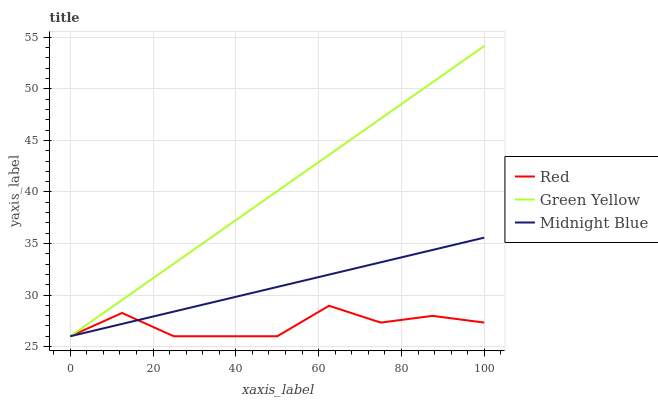Does Red have the minimum area under the curve?
Answer yes or no. Yes. Does Green Yellow have the maximum area under the curve?
Answer yes or no. Yes. Does Midnight Blue have the minimum area under the curve?
Answer yes or no. No. Does Midnight Blue have the maximum area under the curve?
Answer yes or no. No. Is Green Yellow the smoothest?
Answer yes or no. Yes. Is Red the roughest?
Answer yes or no. Yes. Is Midnight Blue the smoothest?
Answer yes or no. No. Is Midnight Blue the roughest?
Answer yes or no. No. Does Green Yellow have the lowest value?
Answer yes or no. Yes. Does Green Yellow have the highest value?
Answer yes or no. Yes. Does Midnight Blue have the highest value?
Answer yes or no. No. Does Red intersect Midnight Blue?
Answer yes or no. Yes. Is Red less than Midnight Blue?
Answer yes or no. No. Is Red greater than Midnight Blue?
Answer yes or no. No. 